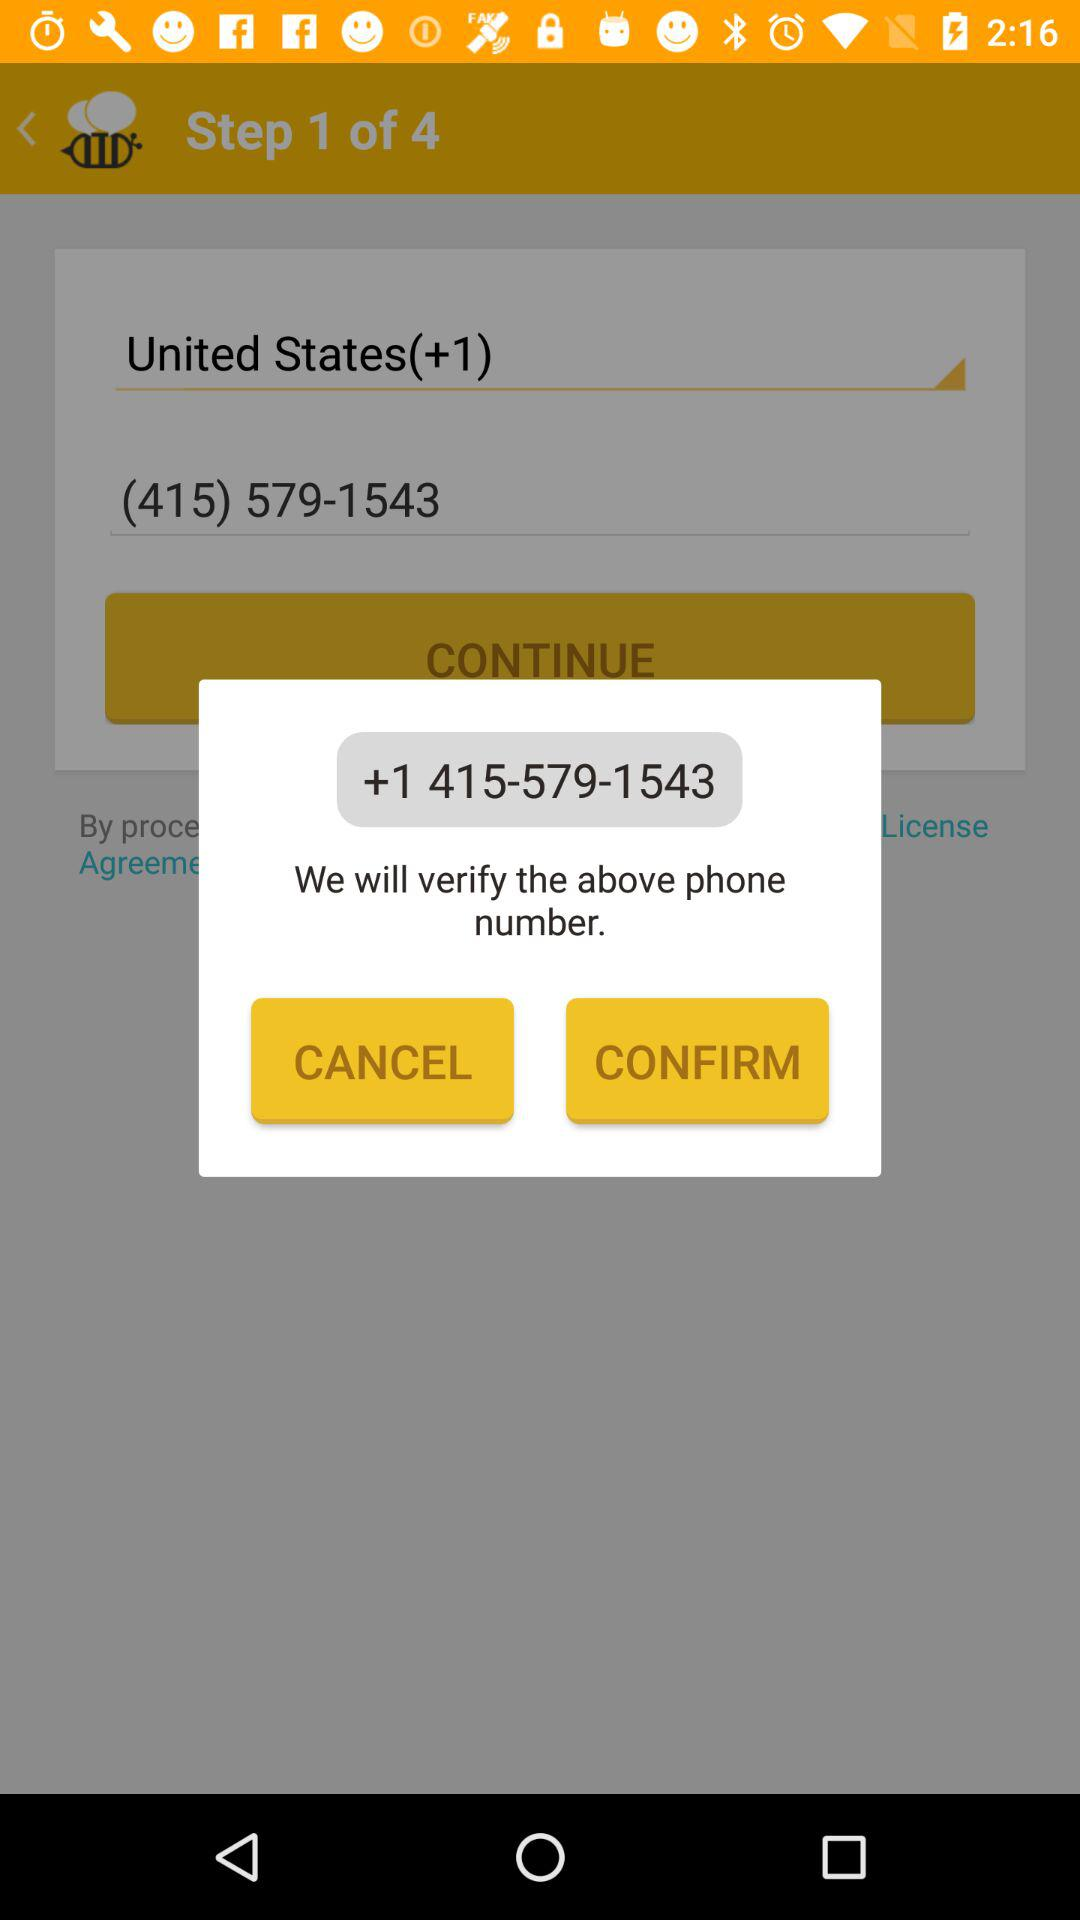What is the phone number? The phone number is +1 415-579-1543. 